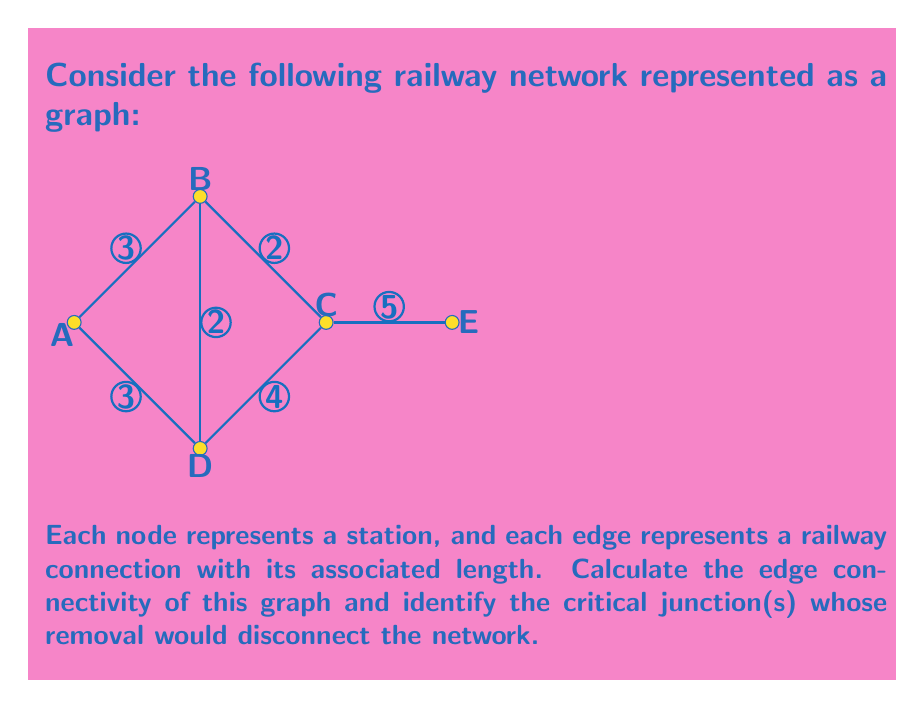Can you answer this question? To solve this problem, we'll follow these steps:

1) First, let's understand what edge connectivity means:
   The edge connectivity of a graph is the minimum number of edges that need to be removed to disconnect the graph.

2) To find the edge connectivity, we need to identify the minimum cut set of the graph.
   A cut set is a set of edges whose removal disconnects the graph.

3) Examining the graph:
   - Removing edge CE disconnects node E from the rest of the graph.
   - Removing edges BC and BD disconnects the graph into two components: {A,D} and {B,C,E}.
   - No single edge removal (except CE) can disconnect the graph.

4) The minimum cut set consists of either:
   a) The single edge CE, or
   b) The pair of edges BC and BD

5) Since the smaller of these two options is the single edge CE, the edge connectivity of the graph is 1.

6) To identify critical junctions, we look for nodes whose removal (along with all incident edges) would disconnect the graph:
   - Removing A, B, or D leaves the graph connected.
   - Removing C disconnects E from the rest of the graph.
   - Removing E only removes itself.

7) Therefore, the critical junction is node C, as its removal would disconnect the network.
Answer: Edge connectivity: 1; Critical junction: C 